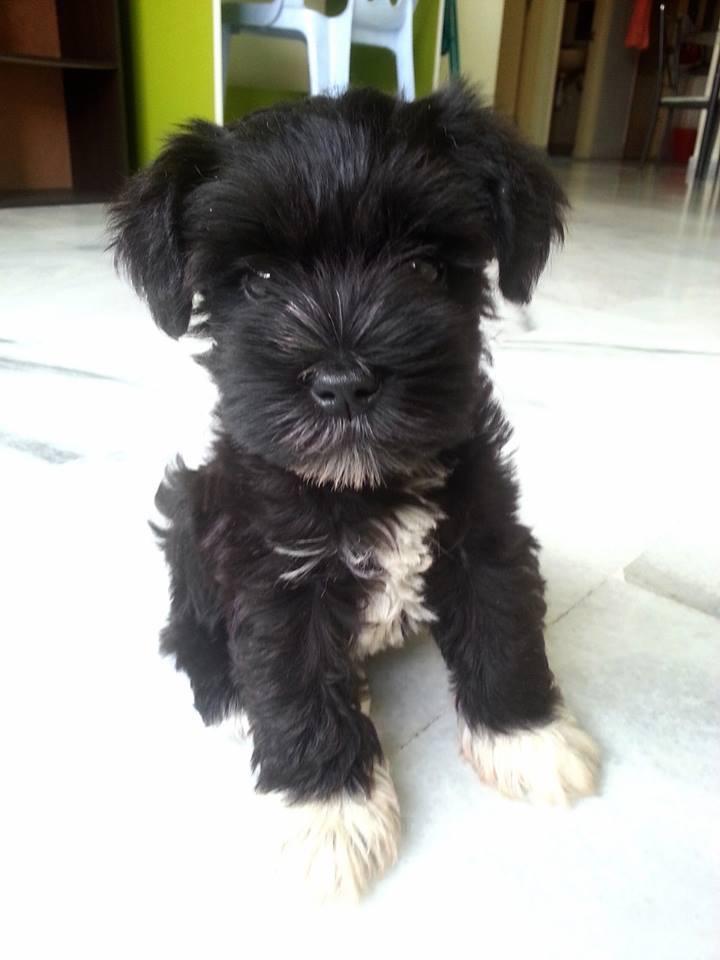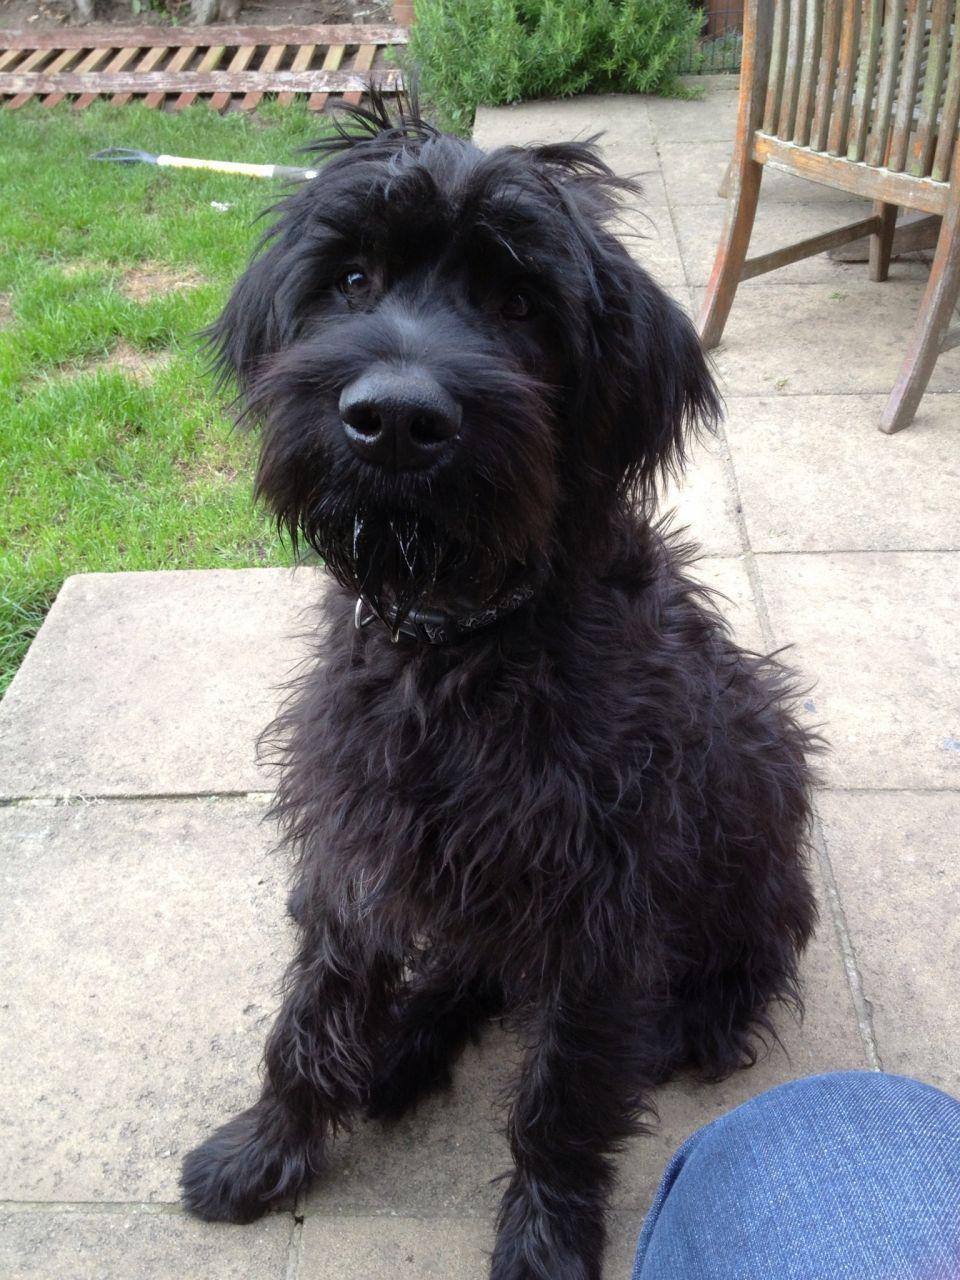The first image is the image on the left, the second image is the image on the right. For the images shown, is this caption "There are at most two dogs." true? Answer yes or no. Yes. The first image is the image on the left, the second image is the image on the right. Analyze the images presented: Is the assertion "One of the images has two dogs that are sitting." valid? Answer yes or no. No. 